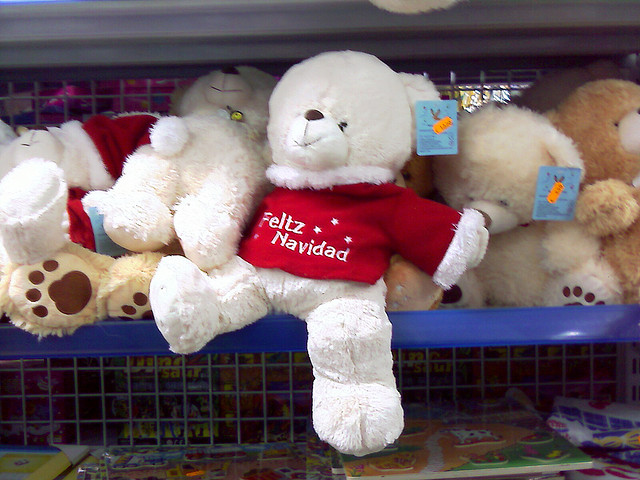How many teddy bears can be seen? In the image, there is only one teddy bear visible, wearing a red shirt with the greeting 'Feliz Navidad' which means 'Merry Christmas' in Spanish. It's nestled among other stuffed animals on a store shelf. 